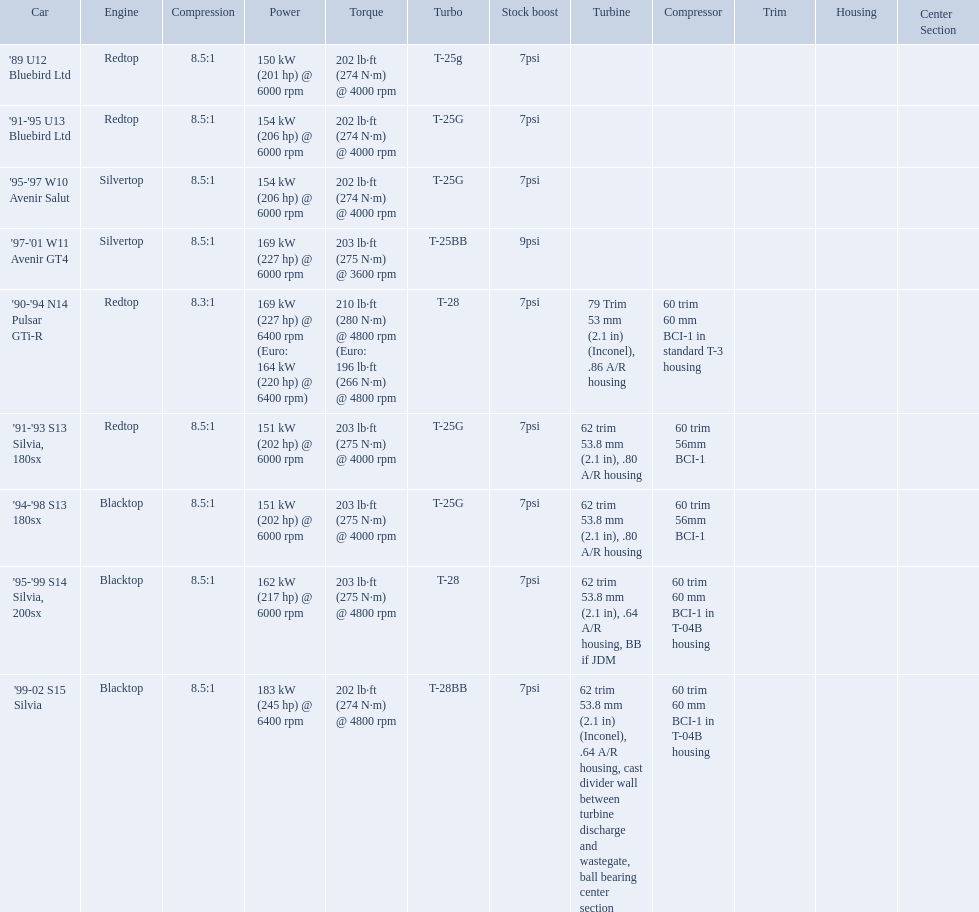Which cars featured blacktop engines? '94-'98 S13 180sx, '95-'99 S14 Silvia, 200sx, '99-02 S15 Silvia. Which of these had t-04b compressor housings? '95-'99 S14 Silvia, 200sx, '99-02 S15 Silvia. Which one of these has the highest horsepower? '99-02 S15 Silvia. What are the listed hp of the cars? 150 kW (201 hp) @ 6000 rpm, 154 kW (206 hp) @ 6000 rpm, 154 kW (206 hp) @ 6000 rpm, 169 kW (227 hp) @ 6000 rpm, 169 kW (227 hp) @ 6400 rpm (Euro: 164 kW (220 hp) @ 6400 rpm), 151 kW (202 hp) @ 6000 rpm, 151 kW (202 hp) @ 6000 rpm, 162 kW (217 hp) @ 6000 rpm, 183 kW (245 hp) @ 6400 rpm. Which is the only car with over 230 hp? '99-02 S15 Silvia. Write the full table. {'header': ['Car', 'Engine', 'Compression', 'Power', 'Torque', 'Turbo', 'Stock boost', 'Turbine', 'Compressor', 'Trim', 'Housing', 'Center Section'], 'rows': [["'89 U12 Bluebird Ltd", 'Redtop', '8.5:1', '150\xa0kW (201\xa0hp) @ 6000 rpm', '202\xa0lb·ft (274\xa0N·m) @ 4000 rpm', 'T-25g', '7psi', '', '', '', '', ''], ["'91-'95 U13 Bluebird Ltd", 'Redtop', '8.5:1', '154\xa0kW (206\xa0hp) @ 6000 rpm', '202\xa0lb·ft (274\xa0N·m) @ 4000 rpm', 'T-25G', '7psi', '', '', '', '', ''], ["'95-'97 W10 Avenir Salut", 'Silvertop', '8.5:1', '154\xa0kW (206\xa0hp) @ 6000 rpm', '202\xa0lb·ft (274\xa0N·m) @ 4000 rpm', 'T-25G', '7psi', '', '', '', '', ''], ["'97-'01 W11 Avenir GT4", 'Silvertop', '8.5:1', '169\xa0kW (227\xa0hp) @ 6000 rpm', '203\xa0lb·ft (275\xa0N·m) @ 3600 rpm', 'T-25BB', '9psi', '', '', '', '', ''], ["'90-'94 N14 Pulsar GTi-R", 'Redtop', '8.3:1', '169\xa0kW (227\xa0hp) @ 6400 rpm (Euro: 164\xa0kW (220\xa0hp) @ 6400 rpm)', '210\xa0lb·ft (280\xa0N·m) @ 4800 rpm (Euro: 196\xa0lb·ft (266\xa0N·m) @ 4800 rpm', 'T-28', '7psi', '79 Trim 53\xa0mm (2.1\xa0in) (Inconel), .86 A/R housing', '60 trim 60\xa0mm BCI-1 in standard T-3 housing', '', '', ''], ["'91-'93 S13 Silvia, 180sx", 'Redtop', '8.5:1', '151\xa0kW (202\xa0hp) @ 6000 rpm', '203\xa0lb·ft (275\xa0N·m) @ 4000 rpm', 'T-25G', '7psi', '62 trim 53.8\xa0mm (2.1\xa0in), .80 A/R housing', '60 trim 56mm BCI-1', '', '', ''], ["'94-'98 S13 180sx", 'Blacktop', '8.5:1', '151\xa0kW (202\xa0hp) @ 6000 rpm', '203\xa0lb·ft (275\xa0N·m) @ 4000 rpm', 'T-25G', '7psi', '62 trim 53.8\xa0mm (2.1\xa0in), .80 A/R housing', '60 trim 56mm BCI-1', '', '', ''], ["'95-'99 S14 Silvia, 200sx", 'Blacktop', '8.5:1', '162\xa0kW (217\xa0hp) @ 6000 rpm', '203\xa0lb·ft (275\xa0N·m) @ 4800 rpm', 'T-28', '7psi', '62 trim 53.8\xa0mm (2.1\xa0in), .64 A/R housing, BB if JDM', '60 trim 60\xa0mm BCI-1 in T-04B housing', '', '', ''], ["'99-02 S15 Silvia", 'Blacktop', '8.5:1', '183\xa0kW (245\xa0hp) @ 6400 rpm', '202\xa0lb·ft (274\xa0N·m) @ 4800 rpm', 'T-28BB', '7psi', '62 trim 53.8\xa0mm (2.1\xa0in) (Inconel), .64 A/R housing, cast divider wall between turbine discharge and wastegate, ball bearing center section', '60 trim 60\xa0mm BCI-1 in T-04B housing', '', '', '']]} What are all the cars? '89 U12 Bluebird Ltd, '91-'95 U13 Bluebird Ltd, '95-'97 W10 Avenir Salut, '97-'01 W11 Avenir GT4, '90-'94 N14 Pulsar GTi-R, '91-'93 S13 Silvia, 180sx, '94-'98 S13 180sx, '95-'99 S14 Silvia, 200sx, '99-02 S15 Silvia. What are their stock boosts? 7psi, 7psi, 7psi, 9psi, 7psi, 7psi, 7psi, 7psi, 7psi. And which car has the highest stock boost? '97-'01 W11 Avenir GT4. Which cars list turbine details? '90-'94 N14 Pulsar GTi-R, '91-'93 S13 Silvia, 180sx, '94-'98 S13 180sx, '95-'99 S14 Silvia, 200sx, '99-02 S15 Silvia. Which of these hit their peak hp at the highest rpm? '90-'94 N14 Pulsar GTi-R, '99-02 S15 Silvia. Of those what is the compression of the only engine that isn't blacktop?? 8.3:1. Would you be able to parse every entry in this table? {'header': ['Car', 'Engine', 'Compression', 'Power', 'Torque', 'Turbo', 'Stock boost', 'Turbine', 'Compressor', 'Trim', 'Housing', 'Center Section'], 'rows': [["'89 U12 Bluebird Ltd", 'Redtop', '8.5:1', '150\xa0kW (201\xa0hp) @ 6000 rpm', '202\xa0lb·ft (274\xa0N·m) @ 4000 rpm', 'T-25g', '7psi', '', '', '', '', ''], ["'91-'95 U13 Bluebird Ltd", 'Redtop', '8.5:1', '154\xa0kW (206\xa0hp) @ 6000 rpm', '202\xa0lb·ft (274\xa0N·m) @ 4000 rpm', 'T-25G', '7psi', '', '', '', '', ''], ["'95-'97 W10 Avenir Salut", 'Silvertop', '8.5:1', '154\xa0kW (206\xa0hp) @ 6000 rpm', '202\xa0lb·ft (274\xa0N·m) @ 4000 rpm', 'T-25G', '7psi', '', '', '', '', ''], ["'97-'01 W11 Avenir GT4", 'Silvertop', '8.5:1', '169\xa0kW (227\xa0hp) @ 6000 rpm', '203\xa0lb·ft (275\xa0N·m) @ 3600 rpm', 'T-25BB', '9psi', '', '', '', '', ''], ["'90-'94 N14 Pulsar GTi-R", 'Redtop', '8.3:1', '169\xa0kW (227\xa0hp) @ 6400 rpm (Euro: 164\xa0kW (220\xa0hp) @ 6400 rpm)', '210\xa0lb·ft (280\xa0N·m) @ 4800 rpm (Euro: 196\xa0lb·ft (266\xa0N·m) @ 4800 rpm', 'T-28', '7psi', '79 Trim 53\xa0mm (2.1\xa0in) (Inconel), .86 A/R housing', '60 trim 60\xa0mm BCI-1 in standard T-3 housing', '', '', ''], ["'91-'93 S13 Silvia, 180sx", 'Redtop', '8.5:1', '151\xa0kW (202\xa0hp) @ 6000 rpm', '203\xa0lb·ft (275\xa0N·m) @ 4000 rpm', 'T-25G', '7psi', '62 trim 53.8\xa0mm (2.1\xa0in), .80 A/R housing', '60 trim 56mm BCI-1', '', '', ''], ["'94-'98 S13 180sx", 'Blacktop', '8.5:1', '151\xa0kW (202\xa0hp) @ 6000 rpm', '203\xa0lb·ft (275\xa0N·m) @ 4000 rpm', 'T-25G', '7psi', '62 trim 53.8\xa0mm (2.1\xa0in), .80 A/R housing', '60 trim 56mm BCI-1', '', '', ''], ["'95-'99 S14 Silvia, 200sx", 'Blacktop', '8.5:1', '162\xa0kW (217\xa0hp) @ 6000 rpm', '203\xa0lb·ft (275\xa0N·m) @ 4800 rpm', 'T-28', '7psi', '62 trim 53.8\xa0mm (2.1\xa0in), .64 A/R housing, BB if JDM', '60 trim 60\xa0mm BCI-1 in T-04B housing', '', '', ''], ["'99-02 S15 Silvia", 'Blacktop', '8.5:1', '183\xa0kW (245\xa0hp) @ 6400 rpm', '202\xa0lb·ft (274\xa0N·m) @ 4800 rpm', 'T-28BB', '7psi', '62 trim 53.8\xa0mm (2.1\xa0in) (Inconel), .64 A/R housing, cast divider wall between turbine discharge and wastegate, ball bearing center section', '60 trim 60\xa0mm BCI-1 in T-04B housing', '', '', '']]} Which of the cars uses the redtop engine? '89 U12 Bluebird Ltd, '91-'95 U13 Bluebird Ltd, '90-'94 N14 Pulsar GTi-R, '91-'93 S13 Silvia, 180sx. Of these, has more than 220 horsepower? '90-'94 N14 Pulsar GTi-R. What is the compression ratio of this car? 8.3:1. 